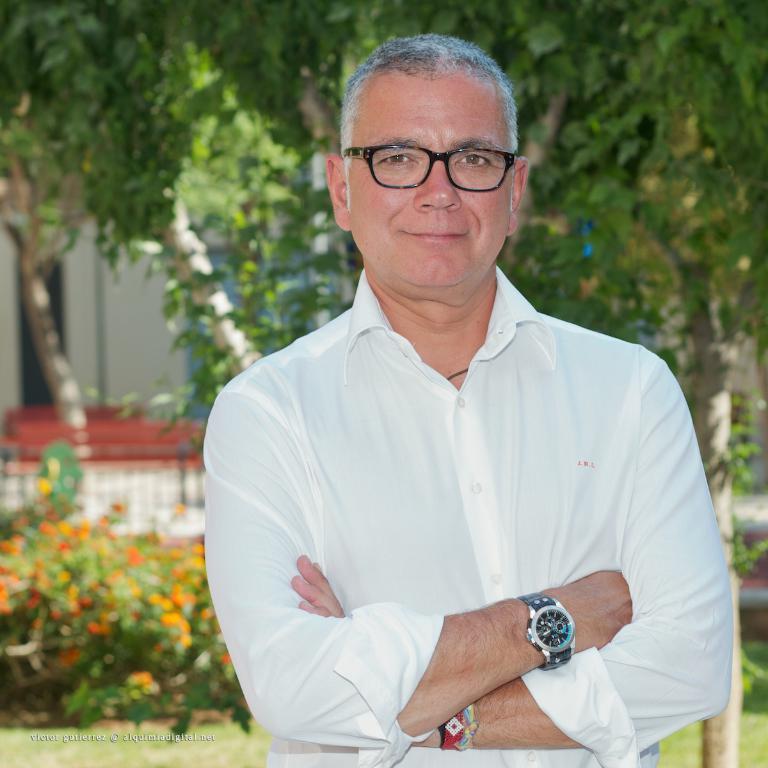How would you summarize this image in a sentence or two? In the center of the image there is a man standing. In the background there are trees, building, plants and grass. 